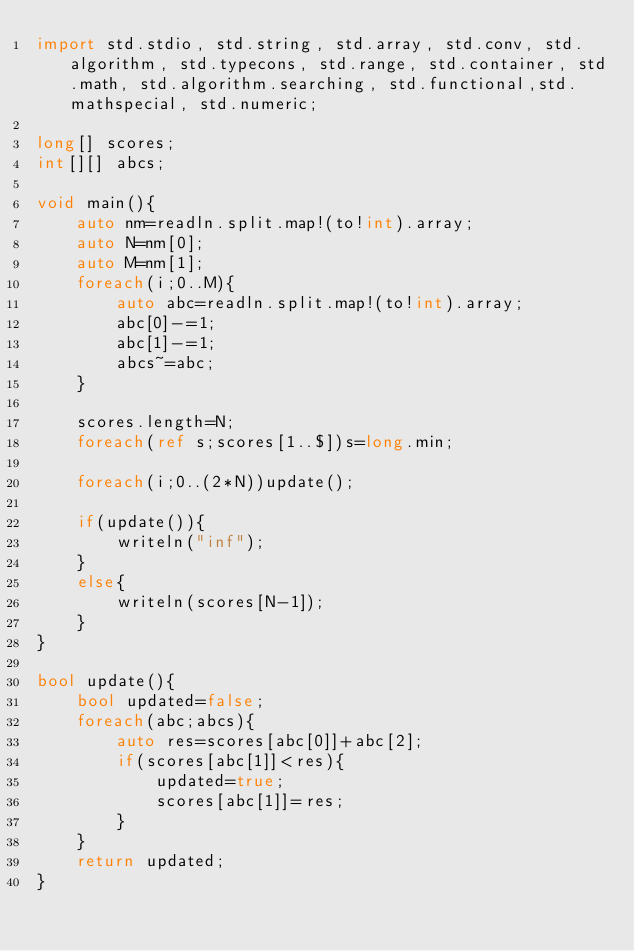<code> <loc_0><loc_0><loc_500><loc_500><_D_>import std.stdio, std.string, std.array, std.conv, std.algorithm, std.typecons, std.range, std.container, std.math, std.algorithm.searching, std.functional,std.mathspecial, std.numeric;

long[] scores;
int[][] abcs;
 
void main(){
    auto nm=readln.split.map!(to!int).array;
    auto N=nm[0];
    auto M=nm[1];
    foreach(i;0..M){
        auto abc=readln.split.map!(to!int).array;
        abc[0]-=1;
        abc[1]-=1;
        abcs~=abc;
    }

    scores.length=N;
    foreach(ref s;scores[1..$])s=long.min;

    foreach(i;0..(2*N))update();

    if(update()){
        writeln("inf");
    }
    else{
        writeln(scores[N-1]);
    }
}

bool update(){
    bool updated=false;
    foreach(abc;abcs){
        auto res=scores[abc[0]]+abc[2];
        if(scores[abc[1]]<res){
            updated=true;
            scores[abc[1]]=res;
        }
    }
    return updated;
}
</code> 